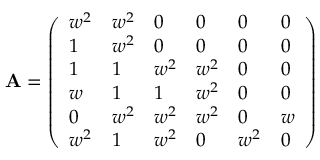<formula> <loc_0><loc_0><loc_500><loc_500>{ A } = { \left ( \begin{array} { l l l l l l } { w ^ { 2 } } & { w ^ { 2 } } & { 0 } & { 0 } & { 0 } & { 0 } \\ { 1 } & { w ^ { 2 } } & { 0 } & { 0 } & { 0 } & { 0 } \\ { 1 } & { 1 } & { w ^ { 2 } } & { w ^ { 2 } } & { 0 } & { 0 } \\ { w } & { 1 } & { 1 } & { w ^ { 2 } } & { 0 } & { 0 } \\ { 0 } & { w ^ { 2 } } & { w ^ { 2 } } & { w ^ { 2 } } & { 0 } & { w } \\ { w ^ { 2 } } & { 1 } & { w ^ { 2 } } & { 0 } & { w ^ { 2 } } & { 0 } \end{array} \right ) }</formula> 